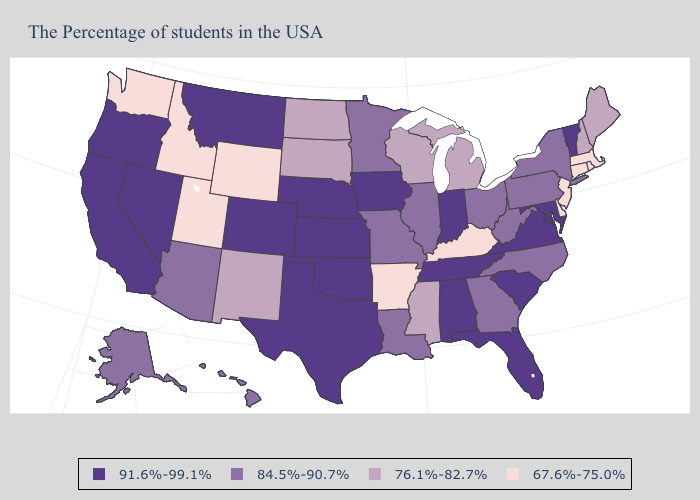Does the map have missing data?
Concise answer only. No. What is the value of Georgia?
Quick response, please. 84.5%-90.7%. Name the states that have a value in the range 76.1%-82.7%?
Be succinct. Maine, New Hampshire, Michigan, Wisconsin, Mississippi, South Dakota, North Dakota, New Mexico. Among the states that border California , which have the lowest value?
Keep it brief. Arizona. Does Oklahoma have the lowest value in the USA?
Answer briefly. No. Does the map have missing data?
Keep it brief. No. Does New Jersey have the highest value in the Northeast?
Answer briefly. No. Which states have the lowest value in the West?
Keep it brief. Wyoming, Utah, Idaho, Washington. Does New Mexico have the highest value in the West?
Give a very brief answer. No. Does the first symbol in the legend represent the smallest category?
Short answer required. No. What is the value of Oklahoma?
Answer briefly. 91.6%-99.1%. Name the states that have a value in the range 91.6%-99.1%?
Be succinct. Vermont, Maryland, Virginia, South Carolina, Florida, Indiana, Alabama, Tennessee, Iowa, Kansas, Nebraska, Oklahoma, Texas, Colorado, Montana, Nevada, California, Oregon. What is the value of Colorado?
Be succinct. 91.6%-99.1%. Which states have the lowest value in the USA?
Be succinct. Massachusetts, Rhode Island, Connecticut, New Jersey, Delaware, Kentucky, Arkansas, Wyoming, Utah, Idaho, Washington. What is the value of Indiana?
Answer briefly. 91.6%-99.1%. 